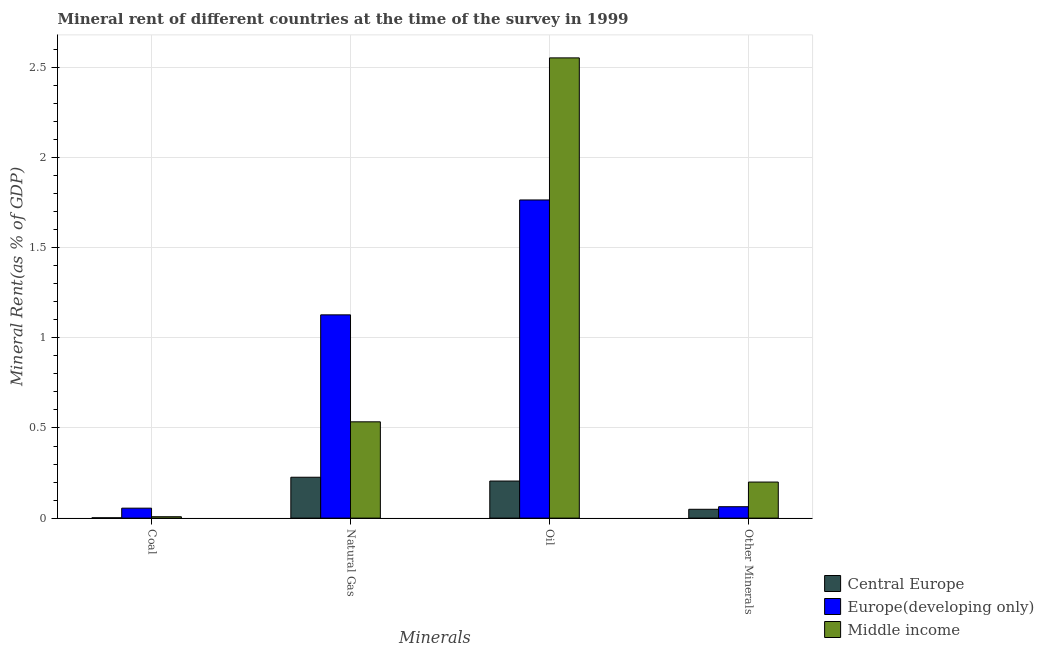How many bars are there on the 3rd tick from the left?
Give a very brief answer. 3. How many bars are there on the 4th tick from the right?
Make the answer very short. 3. What is the label of the 1st group of bars from the left?
Give a very brief answer. Coal. What is the oil rent in Europe(developing only)?
Provide a short and direct response. 1.77. Across all countries, what is the maximum natural gas rent?
Provide a succinct answer. 1.13. Across all countries, what is the minimum  rent of other minerals?
Offer a terse response. 0.05. In which country was the natural gas rent maximum?
Offer a terse response. Europe(developing only). In which country was the natural gas rent minimum?
Keep it short and to the point. Central Europe. What is the total  rent of other minerals in the graph?
Your answer should be very brief. 0.31. What is the difference between the natural gas rent in Central Europe and that in Europe(developing only)?
Make the answer very short. -0.9. What is the difference between the oil rent in Middle income and the coal rent in Central Europe?
Your answer should be compact. 2.55. What is the average natural gas rent per country?
Your answer should be very brief. 0.63. What is the difference between the  rent of other minerals and natural gas rent in Central Europe?
Your response must be concise. -0.18. What is the ratio of the oil rent in Europe(developing only) to that in Central Europe?
Your answer should be very brief. 8.58. What is the difference between the highest and the second highest coal rent?
Your response must be concise. 0.05. What is the difference between the highest and the lowest oil rent?
Your answer should be compact. 2.35. Is it the case that in every country, the sum of the oil rent and natural gas rent is greater than the sum of coal rent and  rent of other minerals?
Offer a terse response. No. What does the 1st bar from the left in Natural Gas represents?
Offer a terse response. Central Europe. Is it the case that in every country, the sum of the coal rent and natural gas rent is greater than the oil rent?
Offer a terse response. No. Are all the bars in the graph horizontal?
Your answer should be very brief. No. How many countries are there in the graph?
Your response must be concise. 3. What is the difference between two consecutive major ticks on the Y-axis?
Offer a terse response. 0.5. Are the values on the major ticks of Y-axis written in scientific E-notation?
Provide a succinct answer. No. Does the graph contain grids?
Offer a terse response. Yes. Where does the legend appear in the graph?
Your answer should be very brief. Bottom right. How are the legend labels stacked?
Give a very brief answer. Vertical. What is the title of the graph?
Ensure brevity in your answer.  Mineral rent of different countries at the time of the survey in 1999. Does "Czech Republic" appear as one of the legend labels in the graph?
Your answer should be compact. No. What is the label or title of the X-axis?
Ensure brevity in your answer.  Minerals. What is the label or title of the Y-axis?
Your answer should be very brief. Mineral Rent(as % of GDP). What is the Mineral Rent(as % of GDP) in Central Europe in Coal?
Give a very brief answer. 0. What is the Mineral Rent(as % of GDP) in Europe(developing only) in Coal?
Your answer should be compact. 0.06. What is the Mineral Rent(as % of GDP) in Middle income in Coal?
Offer a very short reply. 0.01. What is the Mineral Rent(as % of GDP) of Central Europe in Natural Gas?
Ensure brevity in your answer.  0.23. What is the Mineral Rent(as % of GDP) of Europe(developing only) in Natural Gas?
Your answer should be very brief. 1.13. What is the Mineral Rent(as % of GDP) in Middle income in Natural Gas?
Your response must be concise. 0.53. What is the Mineral Rent(as % of GDP) of Central Europe in Oil?
Offer a terse response. 0.21. What is the Mineral Rent(as % of GDP) in Europe(developing only) in Oil?
Ensure brevity in your answer.  1.77. What is the Mineral Rent(as % of GDP) of Middle income in Oil?
Provide a succinct answer. 2.55. What is the Mineral Rent(as % of GDP) of Central Europe in Other Minerals?
Give a very brief answer. 0.05. What is the Mineral Rent(as % of GDP) of Europe(developing only) in Other Minerals?
Ensure brevity in your answer.  0.06. What is the Mineral Rent(as % of GDP) in Middle income in Other Minerals?
Provide a short and direct response. 0.2. Across all Minerals, what is the maximum Mineral Rent(as % of GDP) of Central Europe?
Offer a terse response. 0.23. Across all Minerals, what is the maximum Mineral Rent(as % of GDP) of Europe(developing only)?
Provide a short and direct response. 1.77. Across all Minerals, what is the maximum Mineral Rent(as % of GDP) of Middle income?
Keep it short and to the point. 2.55. Across all Minerals, what is the minimum Mineral Rent(as % of GDP) in Central Europe?
Your response must be concise. 0. Across all Minerals, what is the minimum Mineral Rent(as % of GDP) of Europe(developing only)?
Your answer should be compact. 0.06. Across all Minerals, what is the minimum Mineral Rent(as % of GDP) of Middle income?
Ensure brevity in your answer.  0.01. What is the total Mineral Rent(as % of GDP) in Central Europe in the graph?
Provide a succinct answer. 0.48. What is the total Mineral Rent(as % of GDP) in Europe(developing only) in the graph?
Keep it short and to the point. 3.01. What is the total Mineral Rent(as % of GDP) in Middle income in the graph?
Make the answer very short. 3.3. What is the difference between the Mineral Rent(as % of GDP) of Central Europe in Coal and that in Natural Gas?
Offer a very short reply. -0.23. What is the difference between the Mineral Rent(as % of GDP) in Europe(developing only) in Coal and that in Natural Gas?
Keep it short and to the point. -1.07. What is the difference between the Mineral Rent(as % of GDP) of Middle income in Coal and that in Natural Gas?
Offer a very short reply. -0.53. What is the difference between the Mineral Rent(as % of GDP) of Central Europe in Coal and that in Oil?
Your response must be concise. -0.2. What is the difference between the Mineral Rent(as % of GDP) in Europe(developing only) in Coal and that in Oil?
Your answer should be very brief. -1.71. What is the difference between the Mineral Rent(as % of GDP) in Middle income in Coal and that in Oil?
Make the answer very short. -2.55. What is the difference between the Mineral Rent(as % of GDP) in Central Europe in Coal and that in Other Minerals?
Offer a very short reply. -0.05. What is the difference between the Mineral Rent(as % of GDP) of Europe(developing only) in Coal and that in Other Minerals?
Provide a short and direct response. -0.01. What is the difference between the Mineral Rent(as % of GDP) of Middle income in Coal and that in Other Minerals?
Offer a very short reply. -0.19. What is the difference between the Mineral Rent(as % of GDP) in Central Europe in Natural Gas and that in Oil?
Give a very brief answer. 0.02. What is the difference between the Mineral Rent(as % of GDP) of Europe(developing only) in Natural Gas and that in Oil?
Your answer should be very brief. -0.64. What is the difference between the Mineral Rent(as % of GDP) of Middle income in Natural Gas and that in Oil?
Ensure brevity in your answer.  -2.02. What is the difference between the Mineral Rent(as % of GDP) in Central Europe in Natural Gas and that in Other Minerals?
Ensure brevity in your answer.  0.18. What is the difference between the Mineral Rent(as % of GDP) of Europe(developing only) in Natural Gas and that in Other Minerals?
Your response must be concise. 1.06. What is the difference between the Mineral Rent(as % of GDP) of Middle income in Natural Gas and that in Other Minerals?
Offer a very short reply. 0.33. What is the difference between the Mineral Rent(as % of GDP) of Central Europe in Oil and that in Other Minerals?
Ensure brevity in your answer.  0.16. What is the difference between the Mineral Rent(as % of GDP) of Europe(developing only) in Oil and that in Other Minerals?
Provide a short and direct response. 1.7. What is the difference between the Mineral Rent(as % of GDP) in Middle income in Oil and that in Other Minerals?
Your answer should be very brief. 2.35. What is the difference between the Mineral Rent(as % of GDP) of Central Europe in Coal and the Mineral Rent(as % of GDP) of Europe(developing only) in Natural Gas?
Your response must be concise. -1.13. What is the difference between the Mineral Rent(as % of GDP) in Central Europe in Coal and the Mineral Rent(as % of GDP) in Middle income in Natural Gas?
Provide a succinct answer. -0.53. What is the difference between the Mineral Rent(as % of GDP) of Europe(developing only) in Coal and the Mineral Rent(as % of GDP) of Middle income in Natural Gas?
Your answer should be compact. -0.48. What is the difference between the Mineral Rent(as % of GDP) in Central Europe in Coal and the Mineral Rent(as % of GDP) in Europe(developing only) in Oil?
Your response must be concise. -1.76. What is the difference between the Mineral Rent(as % of GDP) of Central Europe in Coal and the Mineral Rent(as % of GDP) of Middle income in Oil?
Provide a succinct answer. -2.55. What is the difference between the Mineral Rent(as % of GDP) of Europe(developing only) in Coal and the Mineral Rent(as % of GDP) of Middle income in Oil?
Make the answer very short. -2.5. What is the difference between the Mineral Rent(as % of GDP) of Central Europe in Coal and the Mineral Rent(as % of GDP) of Europe(developing only) in Other Minerals?
Provide a short and direct response. -0.06. What is the difference between the Mineral Rent(as % of GDP) in Central Europe in Coal and the Mineral Rent(as % of GDP) in Middle income in Other Minerals?
Offer a terse response. -0.2. What is the difference between the Mineral Rent(as % of GDP) in Europe(developing only) in Coal and the Mineral Rent(as % of GDP) in Middle income in Other Minerals?
Your answer should be very brief. -0.14. What is the difference between the Mineral Rent(as % of GDP) in Central Europe in Natural Gas and the Mineral Rent(as % of GDP) in Europe(developing only) in Oil?
Your answer should be very brief. -1.54. What is the difference between the Mineral Rent(as % of GDP) in Central Europe in Natural Gas and the Mineral Rent(as % of GDP) in Middle income in Oil?
Provide a succinct answer. -2.33. What is the difference between the Mineral Rent(as % of GDP) in Europe(developing only) in Natural Gas and the Mineral Rent(as % of GDP) in Middle income in Oil?
Give a very brief answer. -1.43. What is the difference between the Mineral Rent(as % of GDP) of Central Europe in Natural Gas and the Mineral Rent(as % of GDP) of Europe(developing only) in Other Minerals?
Ensure brevity in your answer.  0.16. What is the difference between the Mineral Rent(as % of GDP) in Central Europe in Natural Gas and the Mineral Rent(as % of GDP) in Middle income in Other Minerals?
Your answer should be very brief. 0.03. What is the difference between the Mineral Rent(as % of GDP) of Europe(developing only) in Natural Gas and the Mineral Rent(as % of GDP) of Middle income in Other Minerals?
Your answer should be very brief. 0.93. What is the difference between the Mineral Rent(as % of GDP) of Central Europe in Oil and the Mineral Rent(as % of GDP) of Europe(developing only) in Other Minerals?
Provide a succinct answer. 0.14. What is the difference between the Mineral Rent(as % of GDP) of Central Europe in Oil and the Mineral Rent(as % of GDP) of Middle income in Other Minerals?
Keep it short and to the point. 0.01. What is the difference between the Mineral Rent(as % of GDP) of Europe(developing only) in Oil and the Mineral Rent(as % of GDP) of Middle income in Other Minerals?
Provide a short and direct response. 1.56. What is the average Mineral Rent(as % of GDP) of Central Europe per Minerals?
Provide a short and direct response. 0.12. What is the average Mineral Rent(as % of GDP) in Europe(developing only) per Minerals?
Your answer should be very brief. 0.75. What is the average Mineral Rent(as % of GDP) in Middle income per Minerals?
Your response must be concise. 0.82. What is the difference between the Mineral Rent(as % of GDP) in Central Europe and Mineral Rent(as % of GDP) in Europe(developing only) in Coal?
Provide a short and direct response. -0.05. What is the difference between the Mineral Rent(as % of GDP) of Central Europe and Mineral Rent(as % of GDP) of Middle income in Coal?
Your answer should be compact. -0.01. What is the difference between the Mineral Rent(as % of GDP) in Europe(developing only) and Mineral Rent(as % of GDP) in Middle income in Coal?
Ensure brevity in your answer.  0.05. What is the difference between the Mineral Rent(as % of GDP) in Central Europe and Mineral Rent(as % of GDP) in Europe(developing only) in Natural Gas?
Your response must be concise. -0.9. What is the difference between the Mineral Rent(as % of GDP) in Central Europe and Mineral Rent(as % of GDP) in Middle income in Natural Gas?
Your response must be concise. -0.31. What is the difference between the Mineral Rent(as % of GDP) of Europe(developing only) and Mineral Rent(as % of GDP) of Middle income in Natural Gas?
Provide a succinct answer. 0.59. What is the difference between the Mineral Rent(as % of GDP) of Central Europe and Mineral Rent(as % of GDP) of Europe(developing only) in Oil?
Give a very brief answer. -1.56. What is the difference between the Mineral Rent(as % of GDP) in Central Europe and Mineral Rent(as % of GDP) in Middle income in Oil?
Provide a succinct answer. -2.35. What is the difference between the Mineral Rent(as % of GDP) in Europe(developing only) and Mineral Rent(as % of GDP) in Middle income in Oil?
Your response must be concise. -0.79. What is the difference between the Mineral Rent(as % of GDP) in Central Europe and Mineral Rent(as % of GDP) in Europe(developing only) in Other Minerals?
Provide a succinct answer. -0.01. What is the difference between the Mineral Rent(as % of GDP) of Central Europe and Mineral Rent(as % of GDP) of Middle income in Other Minerals?
Keep it short and to the point. -0.15. What is the difference between the Mineral Rent(as % of GDP) in Europe(developing only) and Mineral Rent(as % of GDP) in Middle income in Other Minerals?
Your answer should be very brief. -0.14. What is the ratio of the Mineral Rent(as % of GDP) of Central Europe in Coal to that in Natural Gas?
Your answer should be compact. 0.01. What is the ratio of the Mineral Rent(as % of GDP) of Europe(developing only) in Coal to that in Natural Gas?
Offer a very short reply. 0.05. What is the ratio of the Mineral Rent(as % of GDP) of Middle income in Coal to that in Natural Gas?
Offer a very short reply. 0.01. What is the ratio of the Mineral Rent(as % of GDP) of Central Europe in Coal to that in Oil?
Keep it short and to the point. 0.01. What is the ratio of the Mineral Rent(as % of GDP) of Europe(developing only) in Coal to that in Oil?
Provide a short and direct response. 0.03. What is the ratio of the Mineral Rent(as % of GDP) in Middle income in Coal to that in Oil?
Provide a short and direct response. 0. What is the ratio of the Mineral Rent(as % of GDP) in Central Europe in Coal to that in Other Minerals?
Your response must be concise. 0.04. What is the ratio of the Mineral Rent(as % of GDP) of Europe(developing only) in Coal to that in Other Minerals?
Ensure brevity in your answer.  0.87. What is the ratio of the Mineral Rent(as % of GDP) of Middle income in Coal to that in Other Minerals?
Ensure brevity in your answer.  0.04. What is the ratio of the Mineral Rent(as % of GDP) in Central Europe in Natural Gas to that in Oil?
Your answer should be compact. 1.1. What is the ratio of the Mineral Rent(as % of GDP) in Europe(developing only) in Natural Gas to that in Oil?
Give a very brief answer. 0.64. What is the ratio of the Mineral Rent(as % of GDP) of Middle income in Natural Gas to that in Oil?
Your answer should be compact. 0.21. What is the ratio of the Mineral Rent(as % of GDP) in Central Europe in Natural Gas to that in Other Minerals?
Your answer should be compact. 4.63. What is the ratio of the Mineral Rent(as % of GDP) in Europe(developing only) in Natural Gas to that in Other Minerals?
Your response must be concise. 17.83. What is the ratio of the Mineral Rent(as % of GDP) of Middle income in Natural Gas to that in Other Minerals?
Make the answer very short. 2.67. What is the ratio of the Mineral Rent(as % of GDP) in Central Europe in Oil to that in Other Minerals?
Provide a short and direct response. 4.2. What is the ratio of the Mineral Rent(as % of GDP) in Europe(developing only) in Oil to that in Other Minerals?
Your response must be concise. 27.9. What is the ratio of the Mineral Rent(as % of GDP) of Middle income in Oil to that in Other Minerals?
Your response must be concise. 12.76. What is the difference between the highest and the second highest Mineral Rent(as % of GDP) of Central Europe?
Your response must be concise. 0.02. What is the difference between the highest and the second highest Mineral Rent(as % of GDP) in Europe(developing only)?
Your response must be concise. 0.64. What is the difference between the highest and the second highest Mineral Rent(as % of GDP) of Middle income?
Make the answer very short. 2.02. What is the difference between the highest and the lowest Mineral Rent(as % of GDP) in Central Europe?
Give a very brief answer. 0.23. What is the difference between the highest and the lowest Mineral Rent(as % of GDP) in Europe(developing only)?
Your answer should be compact. 1.71. What is the difference between the highest and the lowest Mineral Rent(as % of GDP) in Middle income?
Ensure brevity in your answer.  2.55. 